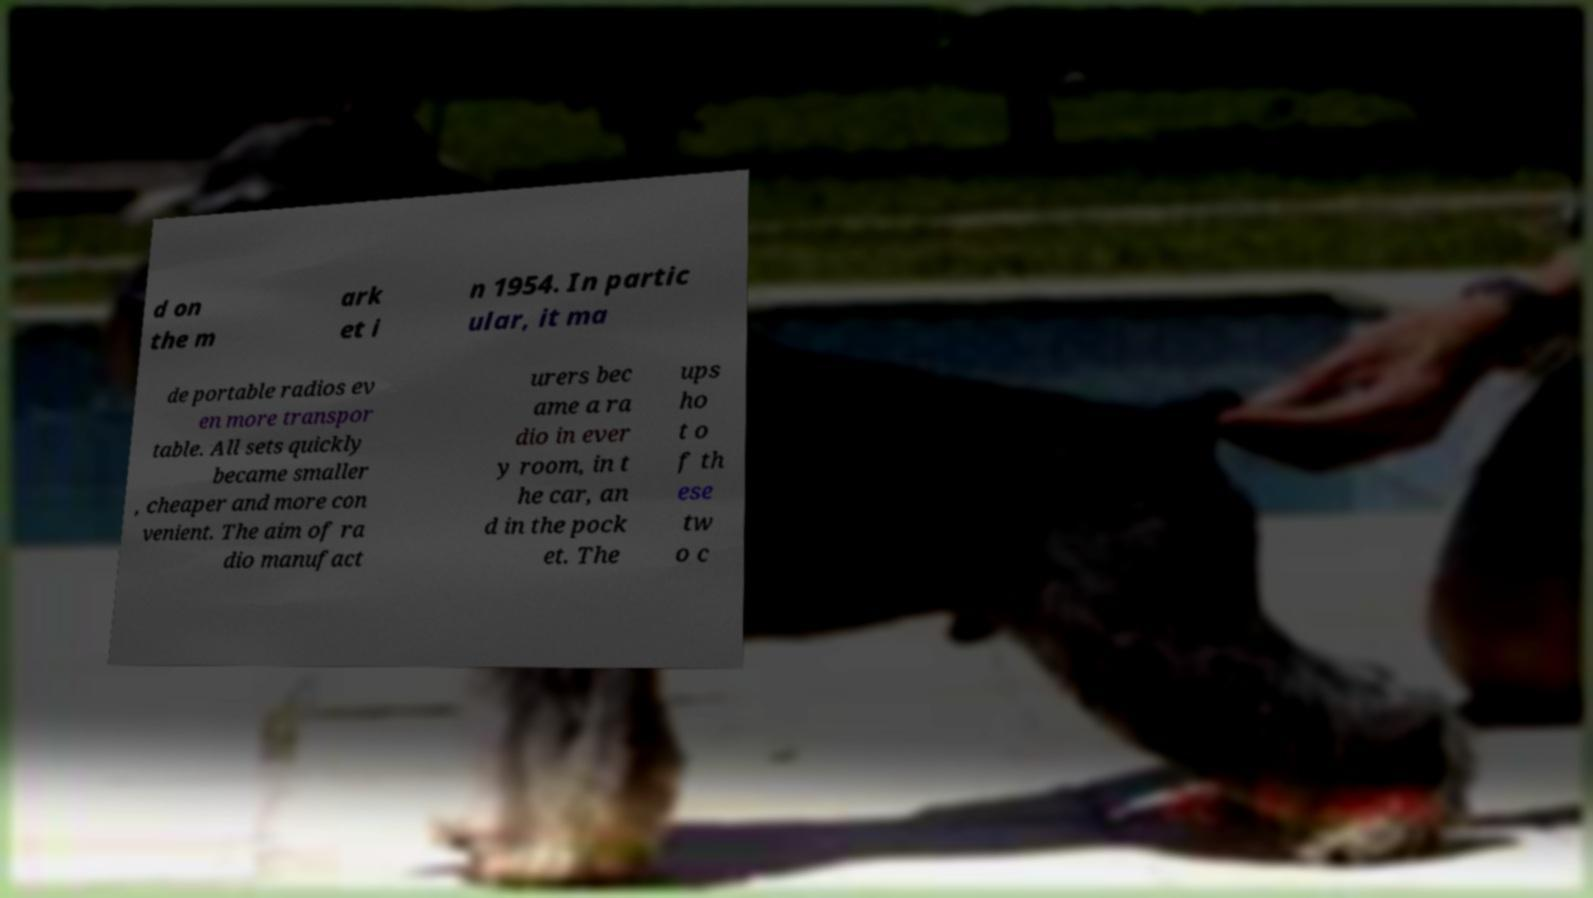What messages or text are displayed in this image? I need them in a readable, typed format. d on the m ark et i n 1954. In partic ular, it ma de portable radios ev en more transpor table. All sets quickly became smaller , cheaper and more con venient. The aim of ra dio manufact urers bec ame a ra dio in ever y room, in t he car, an d in the pock et. The ups ho t o f th ese tw o c 